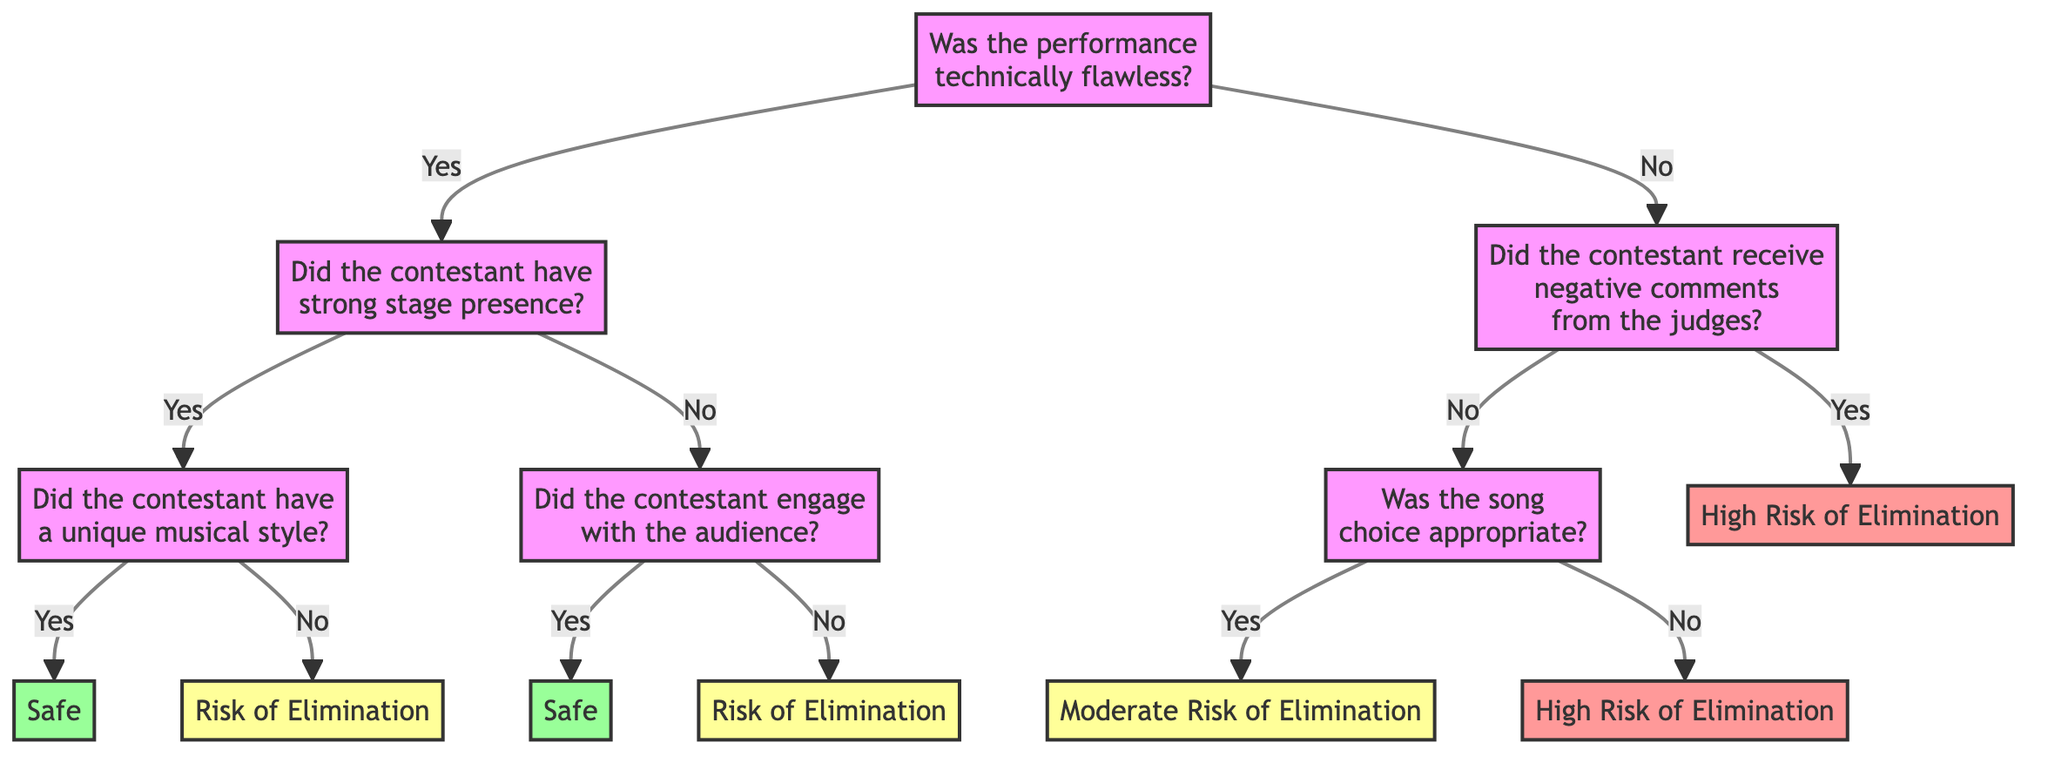What is the first question in the decision tree? The first question in the decision tree is located at the root node. It asks whether the performance was technically flawless.
Answer: Was the performance technically flawless? How many possible outcomes are there in this decision tree? The decision tree leads to four outcomes: Safe, Risk of Elimination, High Risk of Elimination, and Moderate Risk of Elimination. Counting these outcomes gives a total of four.
Answer: Four What happens if the performance is not technically flawless and the contestant receives negative comments from the judges? If the performance is not technically flawless, the next question asks if the contestant received negative comments from the judges. If the answer is yes, they are at high risk of elimination.
Answer: High Risk of Elimination If a contestant has strong stage presence but does not engage with the audience, what is the risk of elimination? If the contestant has strong stage presence, they are further asked if they engaged with the audience. If they did not engage with the audience, they face a risk of elimination.
Answer: Risk of Elimination What outcome is reached if a contestant's performance is technically flawless and has a unique musical style? If the contestant's performance is technically flawless and they have a unique musical style, they will be classified as safe according to the decision tree.
Answer: Safe What is the risk of elimination if the contestant's song choice is inappropriate but did not receive negative comments? In this case, if the song choice is inappropriate, they transition to another question about song choice. Since they did not receive negative comments, they are at moderate risk of elimination.
Answer: Moderate Risk of Elimination What is the relationship between technical flaws in a performance and comments from the judges? If a performance is not technically flawless, the next decision seeks to determine if the contestant received negative comments from the judges, indicating a sequence of evaluations connected directly to the technical quality of the performance.
Answer: Nodes connected What outcome do contestants reach if their performance is flawless but lacks a unique style? If the performance is technically flawless and they do not have a unique musical style, they are at risk of elimination, according to the decision tree.
Answer: Risk of Elimination 